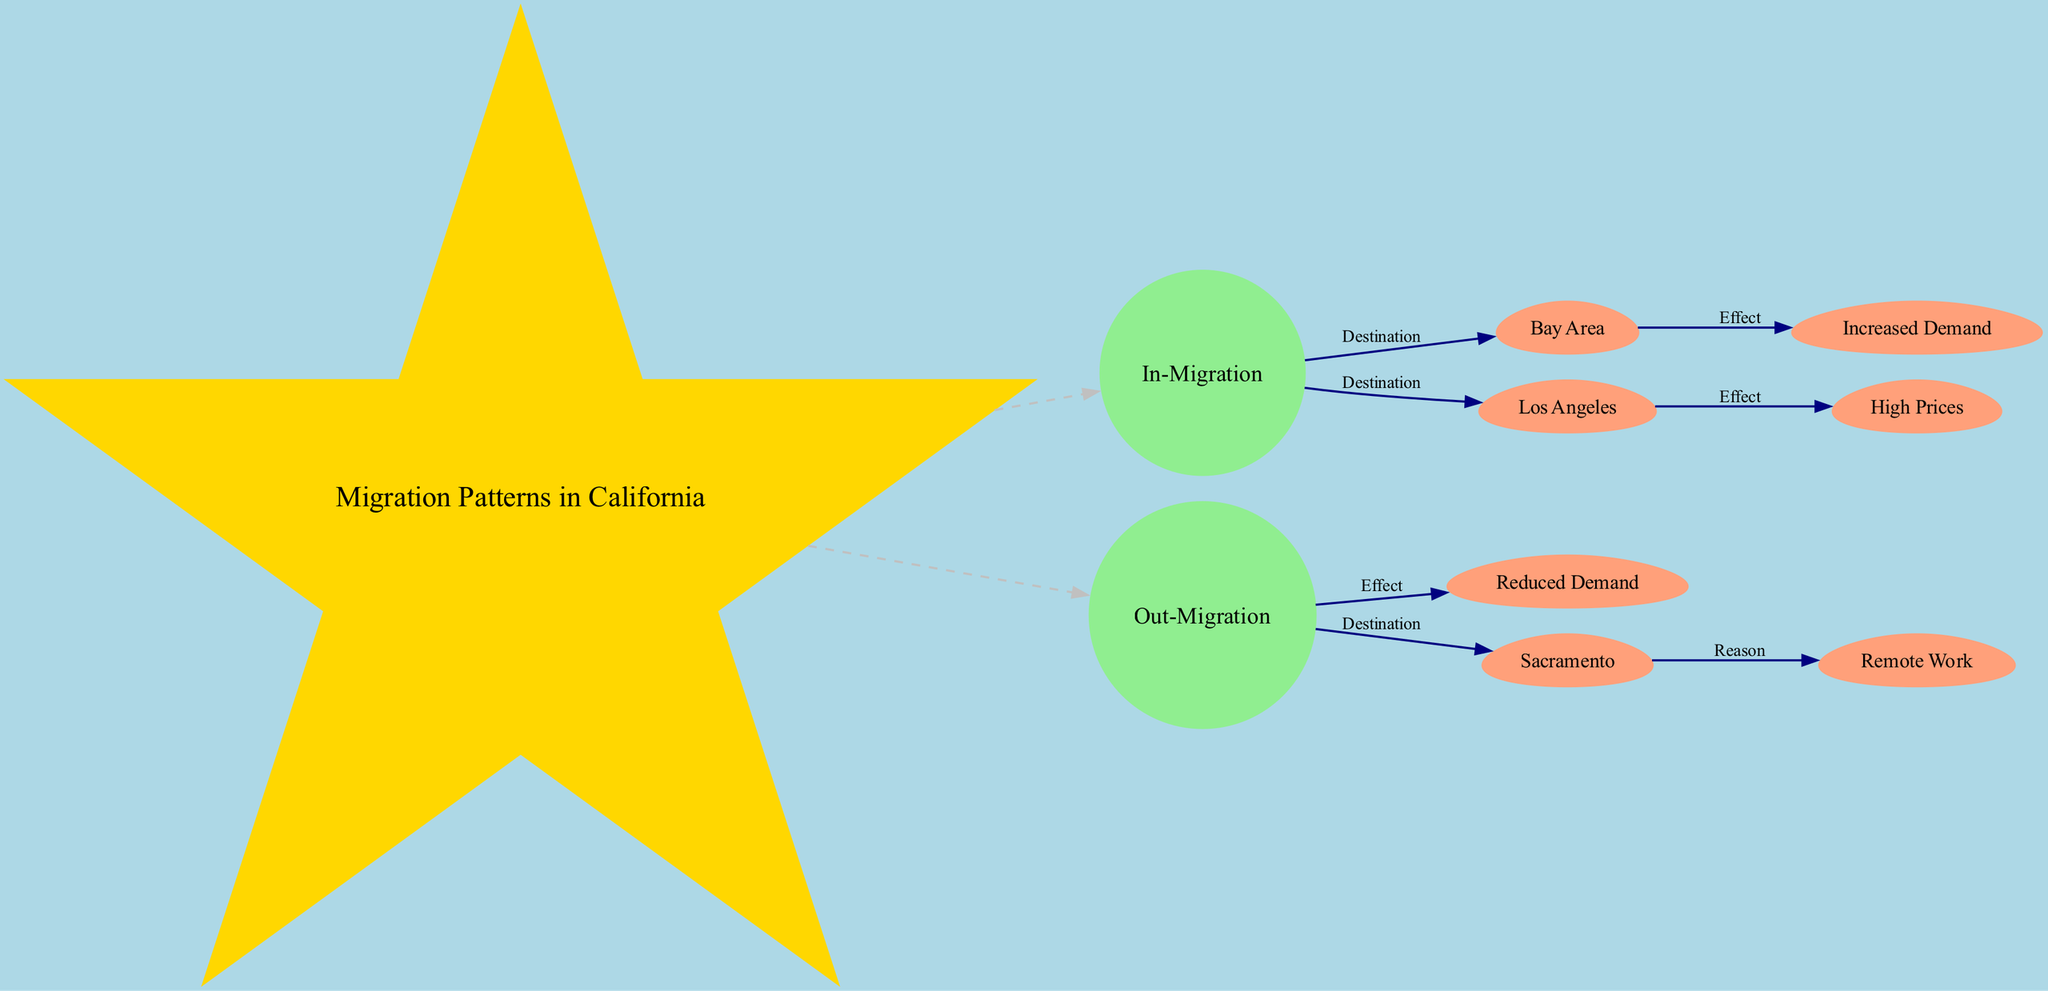What are the two main categories of migration in California depicted in the diagram? The diagram has two planet nodes representing the main types of migration: In-Migration and Out-Migration. These nodes show the flow of people moving into and out of California.
Answer: In-Migration, Out-Migration Which location is associated with increased housing demand? The diagram shows a moon node labeled "Increased Demand" connected to the "Bay Area," indicating that this location experiences higher demand for housing as a result of in-migration.
Answer: Bay Area What effect does out-migration have on housing demand? The diagram connects the "Out-Migration" planet node to the "Reduced Demand" moon node, indicating that out-migration leads to a decrease in housing demand in areas affected by this trend.
Answer: Reduced Demand How many total nodes are in the diagram? The diagram includes one central star node, two planet nodes, and five moon nodes. Adding these together gives a total of eight nodes.
Answer: 8 Which California city is linked to high housing prices? According to the diagram, "Los Angeles" is linked to "High Prices," suggesting that the influx of people into this city drives up housing costs.
Answer: Los Angeles What is the reason associated with out-migration from Sacramento? The diagram shows a connection from Sacramento to "Remote Work," indicating that remote work opportunities motivate people to leave this area, contributing to out-migration.
Answer: Remote Work Which node represents a destination for in-migration besides the Bay Area? The diagram specifies that "Los Angeles," besides "Bay Area," also serves as a destination for people moving into California, as indicated by its connection from the In-Migration node.
Answer: Los Angeles What type of diagram is used to depict migration patterns in California? This diagram is characterized as an Astronomy Diagram, where nodes represent entities in migration, and their relationships are shown with edges indicating direction and effect.
Answer: Astronomy Diagram 